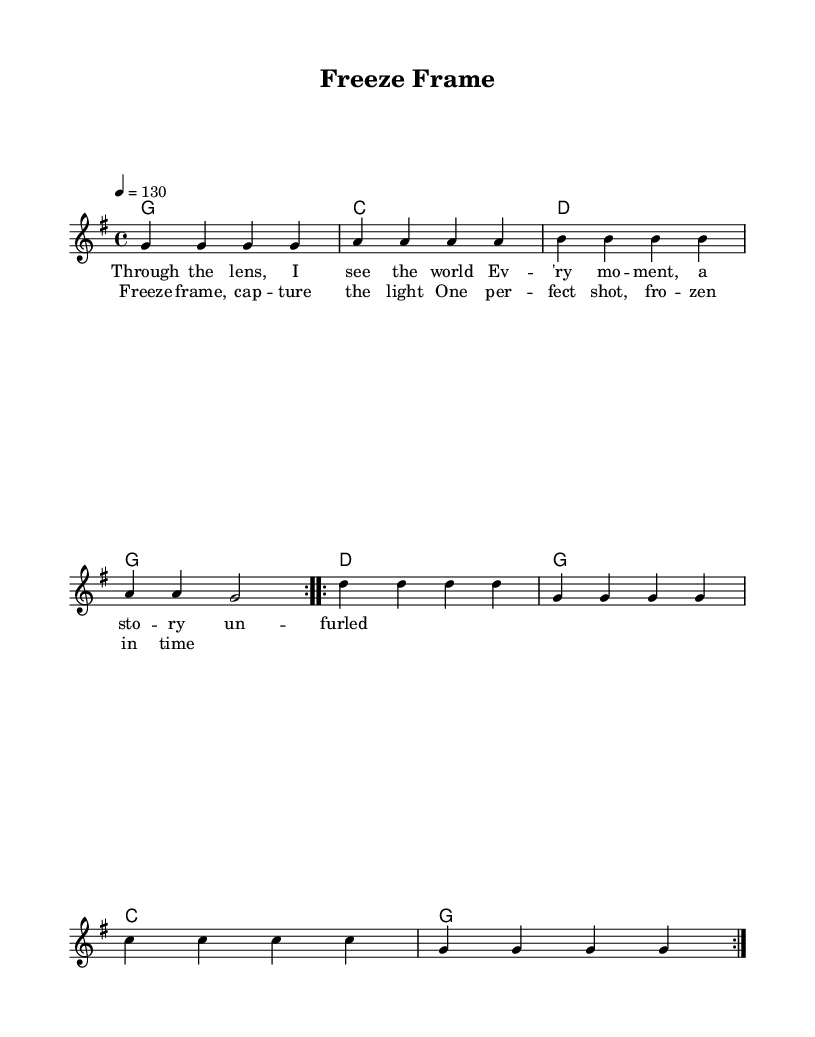What is the key signature of this music? The key signature is G major, which contains one sharp (F#). This can be identified by looking at the key signature indicator at the beginning of the staff.
Answer: G major What is the time signature of this music? The time signature shown in the music is 4/4, indicating that there are four beats per measure. This can be found at the beginning of the score, just after the key signature.
Answer: 4/4 What is the tempo marking for this piece? The tempo marking is indicated as "4 = 130," meaning there are 130 beats per minute. This allows performers to understand how fast to play the piece.
Answer: 130 How many times is the melody repeated in the first section? The melody is repeated two times in the first section, which is indicated by the notation "repeat volta 2." This indicates that the section should be played twice.
Answer: 2 What is the first line of the lyrics? The first line of the lyrics is "Through the lens, I see the world." This can be found directly attached to the melody notes, showing which words correspond with the music.
Answer: Through the lens, I see the world What chord follows G major in the progression? The chord that follows G major in the progression is C major, as it is indicated in the chord mode section after the G chord. This follows the typical progression pattern and can be traced through the chords listed.
Answer: C major What is the thematic focus of the song as inferred from the lyrics? The thematic focus of the song centers around capturing moments in time through photography, as indicated by the lyrics "Freeze frame, capture the light." This reflects the song's title and general mood, suggesting a celebration of moments frozen in time.
Answer: Capturing moments 